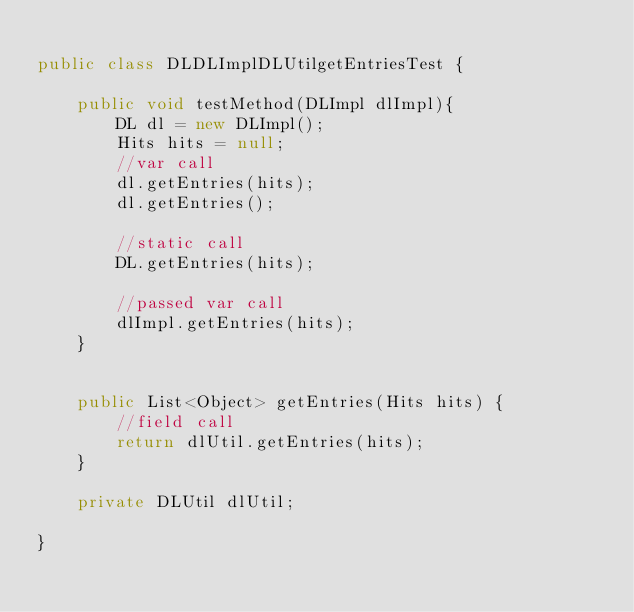<code> <loc_0><loc_0><loc_500><loc_500><_Java_>
public class DLDLImplDLUtilgetEntriesTest {

	public void testMethod(DLImpl dlImpl){
		DL dl = new DLImpl();
		Hits hits = null;
		//var call
		dl.getEntries(hits);
		dl.getEntries();
		
		//static call
		DL.getEntries(hits);
		
		//passed var call
		dlImpl.getEntries(hits);
	}
	

	public List<Object> getEntries(Hits hits) {
		//field call
		return dlUtil.getEntries(hits);
	}
	
	private DLUtil dlUtil;

}
</code> 